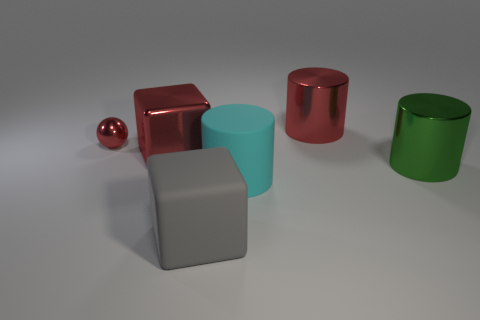Does the gray thing have the same size as the shiny thing that is on the right side of the red metal cylinder?
Offer a terse response. Yes. Is the number of matte cubes behind the green metal object less than the number of large metal balls?
Give a very brief answer. No. There is a red thing that is the same shape as the green shiny object; what is its material?
Keep it short and to the point. Metal. What is the shape of the large thing that is both on the right side of the big red cube and to the left of the large cyan rubber cylinder?
Make the answer very short. Cube. The big red object that is the same material as the big red cube is what shape?
Offer a very short reply. Cylinder. There is a red thing in front of the sphere; what is its material?
Ensure brevity in your answer.  Metal. Do the thing in front of the big cyan rubber cylinder and the metallic ball that is behind the cyan thing have the same size?
Keep it short and to the point. No. The small shiny ball has what color?
Provide a succinct answer. Red. Do the red metallic object right of the large cyan rubber thing and the green shiny thing have the same shape?
Make the answer very short. Yes. What is the big cyan cylinder made of?
Your response must be concise. Rubber. 